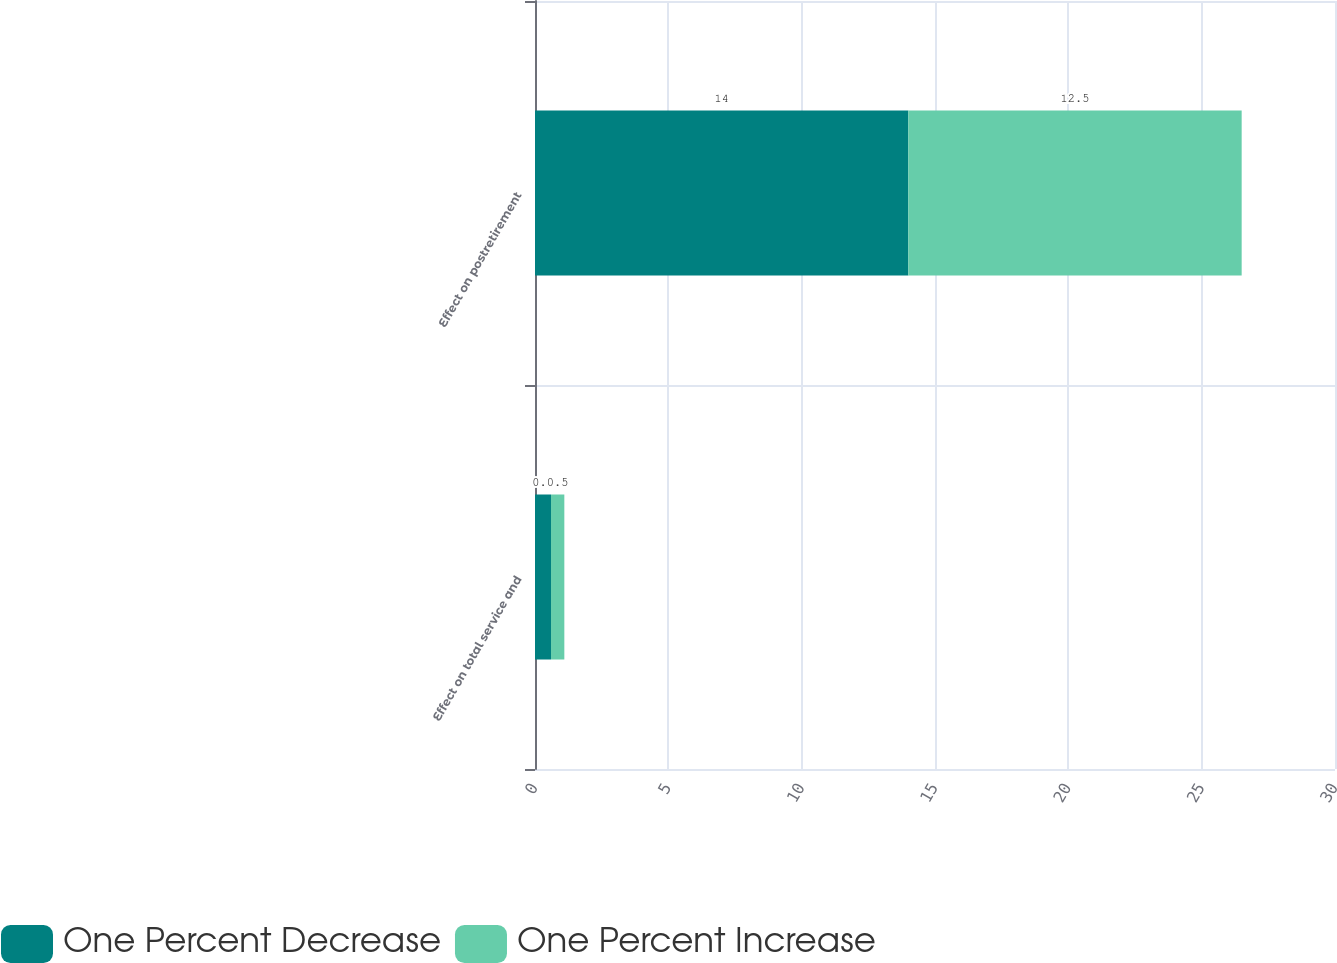<chart> <loc_0><loc_0><loc_500><loc_500><stacked_bar_chart><ecel><fcel>Effect on total service and<fcel>Effect on postretirement<nl><fcel>One Percent Decrease<fcel>0.6<fcel>14<nl><fcel>One Percent Increase<fcel>0.5<fcel>12.5<nl></chart> 